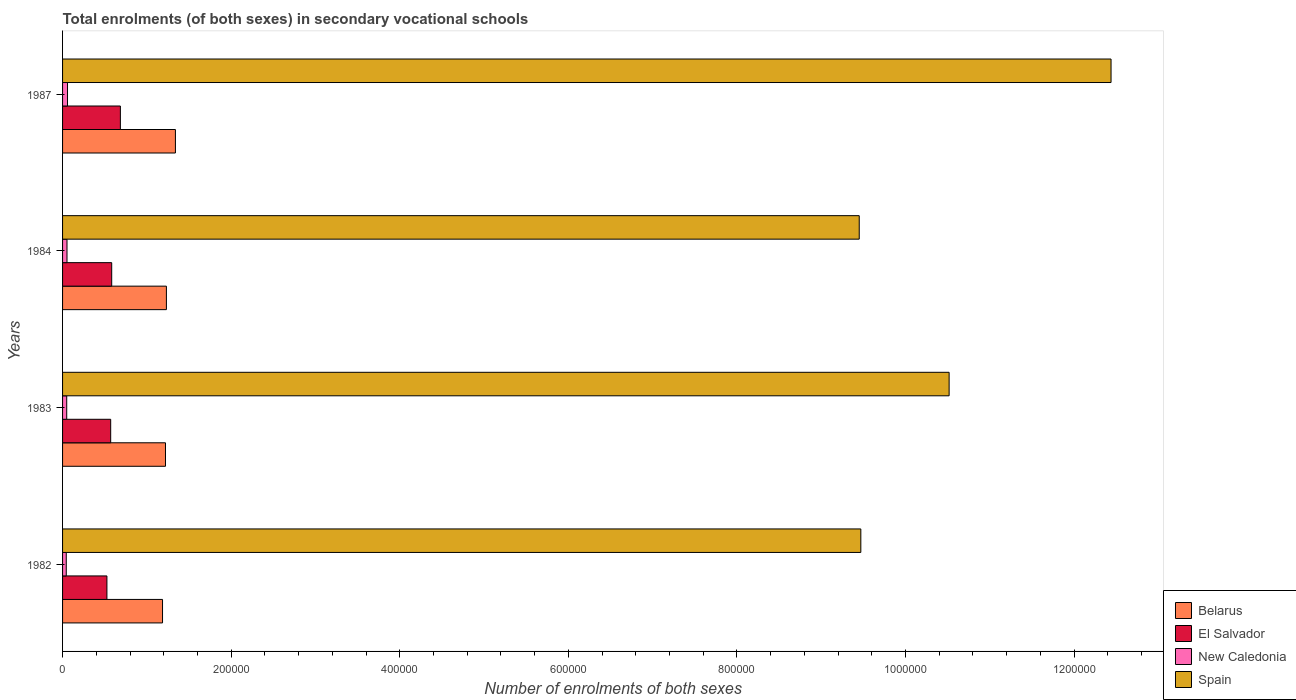How many different coloured bars are there?
Keep it short and to the point. 4. What is the label of the 2nd group of bars from the top?
Offer a very short reply. 1984. What is the number of enrolments in secondary schools in Belarus in 1987?
Give a very brief answer. 1.34e+05. Across all years, what is the maximum number of enrolments in secondary schools in Spain?
Your answer should be compact. 1.24e+06. Across all years, what is the minimum number of enrolments in secondary schools in New Caledonia?
Your answer should be compact. 4382. In which year was the number of enrolments in secondary schools in Spain minimum?
Make the answer very short. 1984. What is the total number of enrolments in secondary schools in Belarus in the graph?
Keep it short and to the point. 4.98e+05. What is the difference between the number of enrolments in secondary schools in El Salvador in 1982 and that in 1984?
Your response must be concise. -5666. What is the difference between the number of enrolments in secondary schools in Spain in 1987 and the number of enrolments in secondary schools in Belarus in 1983?
Your response must be concise. 1.12e+06. What is the average number of enrolments in secondary schools in Belarus per year?
Keep it short and to the point. 1.24e+05. In the year 1987, what is the difference between the number of enrolments in secondary schools in El Salvador and number of enrolments in secondary schools in New Caledonia?
Provide a short and direct response. 6.27e+04. In how many years, is the number of enrolments in secondary schools in New Caledonia greater than 160000 ?
Your answer should be very brief. 0. What is the ratio of the number of enrolments in secondary schools in El Salvador in 1982 to that in 1987?
Give a very brief answer. 0.77. Is the difference between the number of enrolments in secondary schools in El Salvador in 1982 and 1983 greater than the difference between the number of enrolments in secondary schools in New Caledonia in 1982 and 1983?
Offer a terse response. No. What is the difference between the highest and the second highest number of enrolments in secondary schools in Belarus?
Offer a very short reply. 1.07e+04. What is the difference between the highest and the lowest number of enrolments in secondary schools in Spain?
Your answer should be very brief. 2.99e+05. In how many years, is the number of enrolments in secondary schools in Belarus greater than the average number of enrolments in secondary schools in Belarus taken over all years?
Your answer should be compact. 1. What does the 1st bar from the top in 1984 represents?
Keep it short and to the point. Spain. What does the 2nd bar from the bottom in 1984 represents?
Keep it short and to the point. El Salvador. Is it the case that in every year, the sum of the number of enrolments in secondary schools in Spain and number of enrolments in secondary schools in El Salvador is greater than the number of enrolments in secondary schools in New Caledonia?
Your response must be concise. Yes. How many bars are there?
Offer a terse response. 16. How many years are there in the graph?
Provide a short and direct response. 4. Are the values on the major ticks of X-axis written in scientific E-notation?
Provide a succinct answer. No. Does the graph contain any zero values?
Your response must be concise. No. Does the graph contain grids?
Provide a succinct answer. No. Where does the legend appear in the graph?
Offer a terse response. Bottom right. What is the title of the graph?
Your answer should be very brief. Total enrolments (of both sexes) in secondary vocational schools. What is the label or title of the X-axis?
Your answer should be very brief. Number of enrolments of both sexes. What is the label or title of the Y-axis?
Provide a succinct answer. Years. What is the Number of enrolments of both sexes of Belarus in 1982?
Ensure brevity in your answer.  1.19e+05. What is the Number of enrolments of both sexes in El Salvador in 1982?
Ensure brevity in your answer.  5.26e+04. What is the Number of enrolments of both sexes of New Caledonia in 1982?
Provide a succinct answer. 4382. What is the Number of enrolments of both sexes of Spain in 1982?
Give a very brief answer. 9.47e+05. What is the Number of enrolments of both sexes of Belarus in 1983?
Make the answer very short. 1.22e+05. What is the Number of enrolments of both sexes in El Salvador in 1983?
Your answer should be compact. 5.71e+04. What is the Number of enrolments of both sexes of New Caledonia in 1983?
Provide a short and direct response. 4934. What is the Number of enrolments of both sexes in Spain in 1983?
Keep it short and to the point. 1.05e+06. What is the Number of enrolments of both sexes of Belarus in 1984?
Your answer should be compact. 1.23e+05. What is the Number of enrolments of both sexes in El Salvador in 1984?
Offer a terse response. 5.83e+04. What is the Number of enrolments of both sexes of New Caledonia in 1984?
Offer a terse response. 5264. What is the Number of enrolments of both sexes of Spain in 1984?
Your response must be concise. 9.45e+05. What is the Number of enrolments of both sexes in Belarus in 1987?
Your answer should be compact. 1.34e+05. What is the Number of enrolments of both sexes in El Salvador in 1987?
Make the answer very short. 6.86e+04. What is the Number of enrolments of both sexes of New Caledonia in 1987?
Your answer should be compact. 5877. What is the Number of enrolments of both sexes of Spain in 1987?
Make the answer very short. 1.24e+06. Across all years, what is the maximum Number of enrolments of both sexes of Belarus?
Provide a succinct answer. 1.34e+05. Across all years, what is the maximum Number of enrolments of both sexes in El Salvador?
Give a very brief answer. 6.86e+04. Across all years, what is the maximum Number of enrolments of both sexes in New Caledonia?
Provide a short and direct response. 5877. Across all years, what is the maximum Number of enrolments of both sexes in Spain?
Your answer should be compact. 1.24e+06. Across all years, what is the minimum Number of enrolments of both sexes of Belarus?
Provide a short and direct response. 1.19e+05. Across all years, what is the minimum Number of enrolments of both sexes of El Salvador?
Ensure brevity in your answer.  5.26e+04. Across all years, what is the minimum Number of enrolments of both sexes in New Caledonia?
Your answer should be compact. 4382. Across all years, what is the minimum Number of enrolments of both sexes in Spain?
Offer a terse response. 9.45e+05. What is the total Number of enrolments of both sexes of Belarus in the graph?
Ensure brevity in your answer.  4.98e+05. What is the total Number of enrolments of both sexes in El Salvador in the graph?
Offer a very short reply. 2.37e+05. What is the total Number of enrolments of both sexes in New Caledonia in the graph?
Offer a terse response. 2.05e+04. What is the total Number of enrolments of both sexes in Spain in the graph?
Ensure brevity in your answer.  4.19e+06. What is the difference between the Number of enrolments of both sexes of Belarus in 1982 and that in 1983?
Provide a short and direct response. -3500. What is the difference between the Number of enrolments of both sexes in El Salvador in 1982 and that in 1983?
Your answer should be compact. -4467. What is the difference between the Number of enrolments of both sexes in New Caledonia in 1982 and that in 1983?
Your answer should be compact. -552. What is the difference between the Number of enrolments of both sexes of Spain in 1982 and that in 1983?
Provide a short and direct response. -1.05e+05. What is the difference between the Number of enrolments of both sexes in Belarus in 1982 and that in 1984?
Make the answer very short. -4600. What is the difference between the Number of enrolments of both sexes in El Salvador in 1982 and that in 1984?
Provide a succinct answer. -5666. What is the difference between the Number of enrolments of both sexes in New Caledonia in 1982 and that in 1984?
Provide a short and direct response. -882. What is the difference between the Number of enrolments of both sexes in Spain in 1982 and that in 1984?
Offer a very short reply. 1880. What is the difference between the Number of enrolments of both sexes of Belarus in 1982 and that in 1987?
Make the answer very short. -1.53e+04. What is the difference between the Number of enrolments of both sexes of El Salvador in 1982 and that in 1987?
Ensure brevity in your answer.  -1.60e+04. What is the difference between the Number of enrolments of both sexes in New Caledonia in 1982 and that in 1987?
Offer a very short reply. -1495. What is the difference between the Number of enrolments of both sexes of Spain in 1982 and that in 1987?
Your answer should be very brief. -2.97e+05. What is the difference between the Number of enrolments of both sexes of Belarus in 1983 and that in 1984?
Keep it short and to the point. -1100. What is the difference between the Number of enrolments of both sexes in El Salvador in 1983 and that in 1984?
Offer a terse response. -1199. What is the difference between the Number of enrolments of both sexes of New Caledonia in 1983 and that in 1984?
Your answer should be very brief. -330. What is the difference between the Number of enrolments of both sexes in Spain in 1983 and that in 1984?
Give a very brief answer. 1.07e+05. What is the difference between the Number of enrolments of both sexes in Belarus in 1983 and that in 1987?
Provide a succinct answer. -1.18e+04. What is the difference between the Number of enrolments of both sexes of El Salvador in 1983 and that in 1987?
Provide a short and direct response. -1.15e+04. What is the difference between the Number of enrolments of both sexes in New Caledonia in 1983 and that in 1987?
Offer a very short reply. -943. What is the difference between the Number of enrolments of both sexes in Spain in 1983 and that in 1987?
Your answer should be very brief. -1.92e+05. What is the difference between the Number of enrolments of both sexes of Belarus in 1984 and that in 1987?
Your answer should be very brief. -1.07e+04. What is the difference between the Number of enrolments of both sexes in El Salvador in 1984 and that in 1987?
Provide a short and direct response. -1.03e+04. What is the difference between the Number of enrolments of both sexes in New Caledonia in 1984 and that in 1987?
Provide a succinct answer. -613. What is the difference between the Number of enrolments of both sexes in Spain in 1984 and that in 1987?
Offer a very short reply. -2.99e+05. What is the difference between the Number of enrolments of both sexes in Belarus in 1982 and the Number of enrolments of both sexes in El Salvador in 1983?
Your answer should be very brief. 6.15e+04. What is the difference between the Number of enrolments of both sexes of Belarus in 1982 and the Number of enrolments of both sexes of New Caledonia in 1983?
Provide a succinct answer. 1.14e+05. What is the difference between the Number of enrolments of both sexes of Belarus in 1982 and the Number of enrolments of both sexes of Spain in 1983?
Provide a short and direct response. -9.33e+05. What is the difference between the Number of enrolments of both sexes in El Salvador in 1982 and the Number of enrolments of both sexes in New Caledonia in 1983?
Your answer should be compact. 4.77e+04. What is the difference between the Number of enrolments of both sexes in El Salvador in 1982 and the Number of enrolments of both sexes in Spain in 1983?
Offer a terse response. -9.99e+05. What is the difference between the Number of enrolments of both sexes of New Caledonia in 1982 and the Number of enrolments of both sexes of Spain in 1983?
Your answer should be compact. -1.05e+06. What is the difference between the Number of enrolments of both sexes in Belarus in 1982 and the Number of enrolments of both sexes in El Salvador in 1984?
Your answer should be compact. 6.03e+04. What is the difference between the Number of enrolments of both sexes of Belarus in 1982 and the Number of enrolments of both sexes of New Caledonia in 1984?
Your answer should be compact. 1.13e+05. What is the difference between the Number of enrolments of both sexes in Belarus in 1982 and the Number of enrolments of both sexes in Spain in 1984?
Give a very brief answer. -8.27e+05. What is the difference between the Number of enrolments of both sexes of El Salvador in 1982 and the Number of enrolments of both sexes of New Caledonia in 1984?
Your answer should be compact. 4.74e+04. What is the difference between the Number of enrolments of both sexes in El Salvador in 1982 and the Number of enrolments of both sexes in Spain in 1984?
Offer a terse response. -8.93e+05. What is the difference between the Number of enrolments of both sexes in New Caledonia in 1982 and the Number of enrolments of both sexes in Spain in 1984?
Your response must be concise. -9.41e+05. What is the difference between the Number of enrolments of both sexes in Belarus in 1982 and the Number of enrolments of both sexes in El Salvador in 1987?
Give a very brief answer. 5.00e+04. What is the difference between the Number of enrolments of both sexes of Belarus in 1982 and the Number of enrolments of both sexes of New Caledonia in 1987?
Offer a very short reply. 1.13e+05. What is the difference between the Number of enrolments of both sexes in Belarus in 1982 and the Number of enrolments of both sexes in Spain in 1987?
Ensure brevity in your answer.  -1.13e+06. What is the difference between the Number of enrolments of both sexes in El Salvador in 1982 and the Number of enrolments of both sexes in New Caledonia in 1987?
Offer a very short reply. 4.68e+04. What is the difference between the Number of enrolments of both sexes of El Salvador in 1982 and the Number of enrolments of both sexes of Spain in 1987?
Give a very brief answer. -1.19e+06. What is the difference between the Number of enrolments of both sexes of New Caledonia in 1982 and the Number of enrolments of both sexes of Spain in 1987?
Provide a short and direct response. -1.24e+06. What is the difference between the Number of enrolments of both sexes in Belarus in 1983 and the Number of enrolments of both sexes in El Salvador in 1984?
Make the answer very short. 6.38e+04. What is the difference between the Number of enrolments of both sexes in Belarus in 1983 and the Number of enrolments of both sexes in New Caledonia in 1984?
Ensure brevity in your answer.  1.17e+05. What is the difference between the Number of enrolments of both sexes in Belarus in 1983 and the Number of enrolments of both sexes in Spain in 1984?
Ensure brevity in your answer.  -8.23e+05. What is the difference between the Number of enrolments of both sexes of El Salvador in 1983 and the Number of enrolments of both sexes of New Caledonia in 1984?
Provide a succinct answer. 5.18e+04. What is the difference between the Number of enrolments of both sexes in El Salvador in 1983 and the Number of enrolments of both sexes in Spain in 1984?
Your response must be concise. -8.88e+05. What is the difference between the Number of enrolments of both sexes of New Caledonia in 1983 and the Number of enrolments of both sexes of Spain in 1984?
Make the answer very short. -9.40e+05. What is the difference between the Number of enrolments of both sexes in Belarus in 1983 and the Number of enrolments of both sexes in El Salvador in 1987?
Keep it short and to the point. 5.35e+04. What is the difference between the Number of enrolments of both sexes in Belarus in 1983 and the Number of enrolments of both sexes in New Caledonia in 1987?
Offer a terse response. 1.16e+05. What is the difference between the Number of enrolments of both sexes of Belarus in 1983 and the Number of enrolments of both sexes of Spain in 1987?
Offer a very short reply. -1.12e+06. What is the difference between the Number of enrolments of both sexes of El Salvador in 1983 and the Number of enrolments of both sexes of New Caledonia in 1987?
Offer a terse response. 5.12e+04. What is the difference between the Number of enrolments of both sexes in El Salvador in 1983 and the Number of enrolments of both sexes in Spain in 1987?
Keep it short and to the point. -1.19e+06. What is the difference between the Number of enrolments of both sexes of New Caledonia in 1983 and the Number of enrolments of both sexes of Spain in 1987?
Provide a short and direct response. -1.24e+06. What is the difference between the Number of enrolments of both sexes in Belarus in 1984 and the Number of enrolments of both sexes in El Salvador in 1987?
Offer a very short reply. 5.46e+04. What is the difference between the Number of enrolments of both sexes of Belarus in 1984 and the Number of enrolments of both sexes of New Caledonia in 1987?
Your answer should be compact. 1.17e+05. What is the difference between the Number of enrolments of both sexes of Belarus in 1984 and the Number of enrolments of both sexes of Spain in 1987?
Offer a very short reply. -1.12e+06. What is the difference between the Number of enrolments of both sexes in El Salvador in 1984 and the Number of enrolments of both sexes in New Caledonia in 1987?
Provide a short and direct response. 5.24e+04. What is the difference between the Number of enrolments of both sexes of El Salvador in 1984 and the Number of enrolments of both sexes of Spain in 1987?
Your response must be concise. -1.19e+06. What is the difference between the Number of enrolments of both sexes in New Caledonia in 1984 and the Number of enrolments of both sexes in Spain in 1987?
Give a very brief answer. -1.24e+06. What is the average Number of enrolments of both sexes in Belarus per year?
Give a very brief answer. 1.24e+05. What is the average Number of enrolments of both sexes of El Salvador per year?
Ensure brevity in your answer.  5.92e+04. What is the average Number of enrolments of both sexes in New Caledonia per year?
Provide a short and direct response. 5114.25. What is the average Number of enrolments of both sexes in Spain per year?
Give a very brief answer. 1.05e+06. In the year 1982, what is the difference between the Number of enrolments of both sexes of Belarus and Number of enrolments of both sexes of El Salvador?
Your answer should be compact. 6.60e+04. In the year 1982, what is the difference between the Number of enrolments of both sexes of Belarus and Number of enrolments of both sexes of New Caledonia?
Your answer should be compact. 1.14e+05. In the year 1982, what is the difference between the Number of enrolments of both sexes in Belarus and Number of enrolments of both sexes in Spain?
Offer a very short reply. -8.28e+05. In the year 1982, what is the difference between the Number of enrolments of both sexes in El Salvador and Number of enrolments of both sexes in New Caledonia?
Make the answer very short. 4.82e+04. In the year 1982, what is the difference between the Number of enrolments of both sexes of El Salvador and Number of enrolments of both sexes of Spain?
Your response must be concise. -8.94e+05. In the year 1982, what is the difference between the Number of enrolments of both sexes of New Caledonia and Number of enrolments of both sexes of Spain?
Make the answer very short. -9.43e+05. In the year 1983, what is the difference between the Number of enrolments of both sexes in Belarus and Number of enrolments of both sexes in El Salvador?
Your answer should be compact. 6.50e+04. In the year 1983, what is the difference between the Number of enrolments of both sexes in Belarus and Number of enrolments of both sexes in New Caledonia?
Provide a short and direct response. 1.17e+05. In the year 1983, what is the difference between the Number of enrolments of both sexes in Belarus and Number of enrolments of both sexes in Spain?
Your answer should be very brief. -9.30e+05. In the year 1983, what is the difference between the Number of enrolments of both sexes in El Salvador and Number of enrolments of both sexes in New Caledonia?
Ensure brevity in your answer.  5.22e+04. In the year 1983, what is the difference between the Number of enrolments of both sexes in El Salvador and Number of enrolments of both sexes in Spain?
Give a very brief answer. -9.95e+05. In the year 1983, what is the difference between the Number of enrolments of both sexes in New Caledonia and Number of enrolments of both sexes in Spain?
Offer a terse response. -1.05e+06. In the year 1984, what is the difference between the Number of enrolments of both sexes of Belarus and Number of enrolments of both sexes of El Salvador?
Your answer should be compact. 6.49e+04. In the year 1984, what is the difference between the Number of enrolments of both sexes of Belarus and Number of enrolments of both sexes of New Caledonia?
Give a very brief answer. 1.18e+05. In the year 1984, what is the difference between the Number of enrolments of both sexes in Belarus and Number of enrolments of both sexes in Spain?
Give a very brief answer. -8.22e+05. In the year 1984, what is the difference between the Number of enrolments of both sexes in El Salvador and Number of enrolments of both sexes in New Caledonia?
Give a very brief answer. 5.30e+04. In the year 1984, what is the difference between the Number of enrolments of both sexes in El Salvador and Number of enrolments of both sexes in Spain?
Make the answer very short. -8.87e+05. In the year 1984, what is the difference between the Number of enrolments of both sexes of New Caledonia and Number of enrolments of both sexes of Spain?
Your response must be concise. -9.40e+05. In the year 1987, what is the difference between the Number of enrolments of both sexes of Belarus and Number of enrolments of both sexes of El Salvador?
Give a very brief answer. 6.53e+04. In the year 1987, what is the difference between the Number of enrolments of both sexes of Belarus and Number of enrolments of both sexes of New Caledonia?
Provide a short and direct response. 1.28e+05. In the year 1987, what is the difference between the Number of enrolments of both sexes in Belarus and Number of enrolments of both sexes in Spain?
Make the answer very short. -1.11e+06. In the year 1987, what is the difference between the Number of enrolments of both sexes in El Salvador and Number of enrolments of both sexes in New Caledonia?
Offer a terse response. 6.27e+04. In the year 1987, what is the difference between the Number of enrolments of both sexes of El Salvador and Number of enrolments of both sexes of Spain?
Ensure brevity in your answer.  -1.18e+06. In the year 1987, what is the difference between the Number of enrolments of both sexes of New Caledonia and Number of enrolments of both sexes of Spain?
Your answer should be very brief. -1.24e+06. What is the ratio of the Number of enrolments of both sexes in Belarus in 1982 to that in 1983?
Your answer should be compact. 0.97. What is the ratio of the Number of enrolments of both sexes of El Salvador in 1982 to that in 1983?
Provide a short and direct response. 0.92. What is the ratio of the Number of enrolments of both sexes in New Caledonia in 1982 to that in 1983?
Your response must be concise. 0.89. What is the ratio of the Number of enrolments of both sexes of Spain in 1982 to that in 1983?
Provide a short and direct response. 0.9. What is the ratio of the Number of enrolments of both sexes of Belarus in 1982 to that in 1984?
Provide a succinct answer. 0.96. What is the ratio of the Number of enrolments of both sexes in El Salvador in 1982 to that in 1984?
Offer a very short reply. 0.9. What is the ratio of the Number of enrolments of both sexes of New Caledonia in 1982 to that in 1984?
Offer a very short reply. 0.83. What is the ratio of the Number of enrolments of both sexes of Belarus in 1982 to that in 1987?
Your answer should be compact. 0.89. What is the ratio of the Number of enrolments of both sexes of El Salvador in 1982 to that in 1987?
Your answer should be compact. 0.77. What is the ratio of the Number of enrolments of both sexes of New Caledonia in 1982 to that in 1987?
Ensure brevity in your answer.  0.75. What is the ratio of the Number of enrolments of both sexes in Spain in 1982 to that in 1987?
Ensure brevity in your answer.  0.76. What is the ratio of the Number of enrolments of both sexes of El Salvador in 1983 to that in 1984?
Your answer should be compact. 0.98. What is the ratio of the Number of enrolments of both sexes in New Caledonia in 1983 to that in 1984?
Make the answer very short. 0.94. What is the ratio of the Number of enrolments of both sexes of Spain in 1983 to that in 1984?
Provide a short and direct response. 1.11. What is the ratio of the Number of enrolments of both sexes in Belarus in 1983 to that in 1987?
Make the answer very short. 0.91. What is the ratio of the Number of enrolments of both sexes in El Salvador in 1983 to that in 1987?
Keep it short and to the point. 0.83. What is the ratio of the Number of enrolments of both sexes of New Caledonia in 1983 to that in 1987?
Offer a terse response. 0.84. What is the ratio of the Number of enrolments of both sexes in Spain in 1983 to that in 1987?
Your answer should be compact. 0.85. What is the ratio of the Number of enrolments of both sexes of Belarus in 1984 to that in 1987?
Make the answer very short. 0.92. What is the ratio of the Number of enrolments of both sexes of El Salvador in 1984 to that in 1987?
Your answer should be compact. 0.85. What is the ratio of the Number of enrolments of both sexes in New Caledonia in 1984 to that in 1987?
Your answer should be very brief. 0.9. What is the ratio of the Number of enrolments of both sexes of Spain in 1984 to that in 1987?
Give a very brief answer. 0.76. What is the difference between the highest and the second highest Number of enrolments of both sexes in Belarus?
Ensure brevity in your answer.  1.07e+04. What is the difference between the highest and the second highest Number of enrolments of both sexes of El Salvador?
Give a very brief answer. 1.03e+04. What is the difference between the highest and the second highest Number of enrolments of both sexes in New Caledonia?
Offer a terse response. 613. What is the difference between the highest and the second highest Number of enrolments of both sexes in Spain?
Provide a succinct answer. 1.92e+05. What is the difference between the highest and the lowest Number of enrolments of both sexes of Belarus?
Offer a very short reply. 1.53e+04. What is the difference between the highest and the lowest Number of enrolments of both sexes in El Salvador?
Provide a succinct answer. 1.60e+04. What is the difference between the highest and the lowest Number of enrolments of both sexes of New Caledonia?
Provide a succinct answer. 1495. What is the difference between the highest and the lowest Number of enrolments of both sexes in Spain?
Provide a succinct answer. 2.99e+05. 